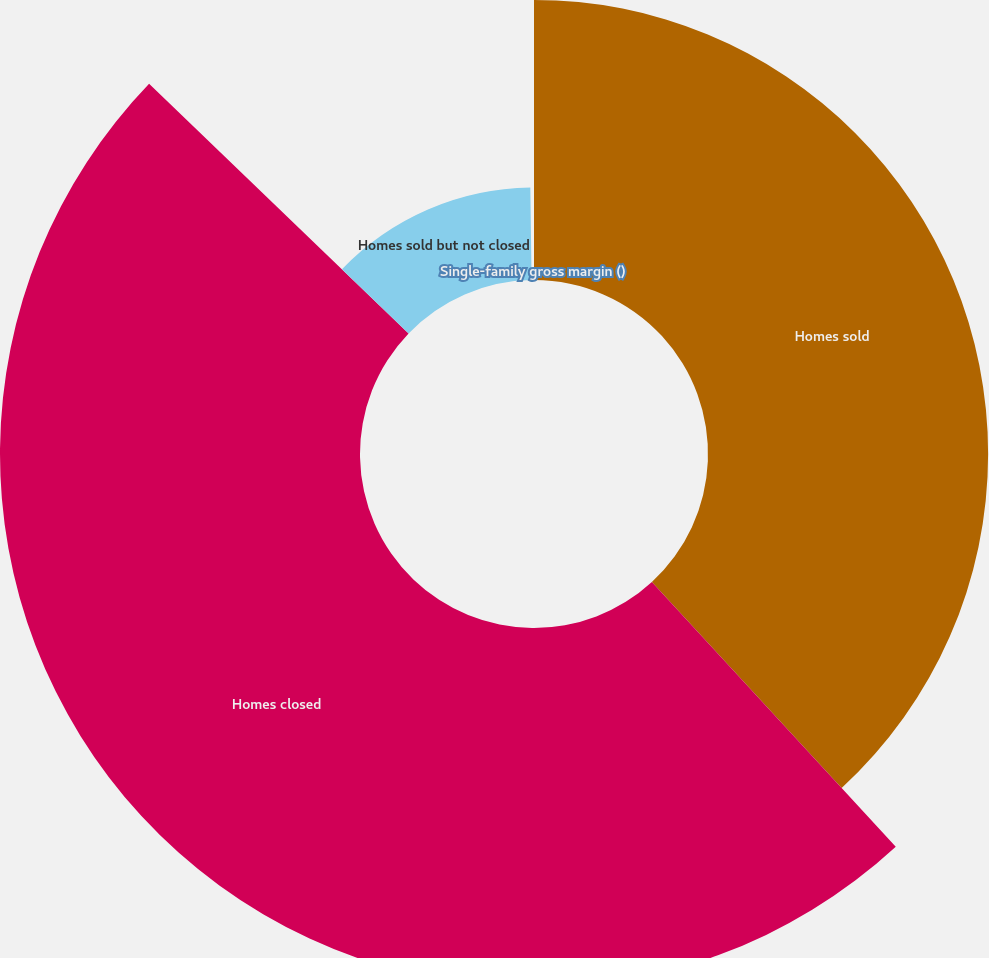Convert chart to OTSL. <chart><loc_0><loc_0><loc_500><loc_500><pie_chart><fcel>Homes sold<fcel>Homes closed<fcel>Homes sold but not closed<fcel>Single-family gross margin ()<nl><fcel>38.15%<fcel>49.03%<fcel>12.59%<fcel>0.22%<nl></chart> 